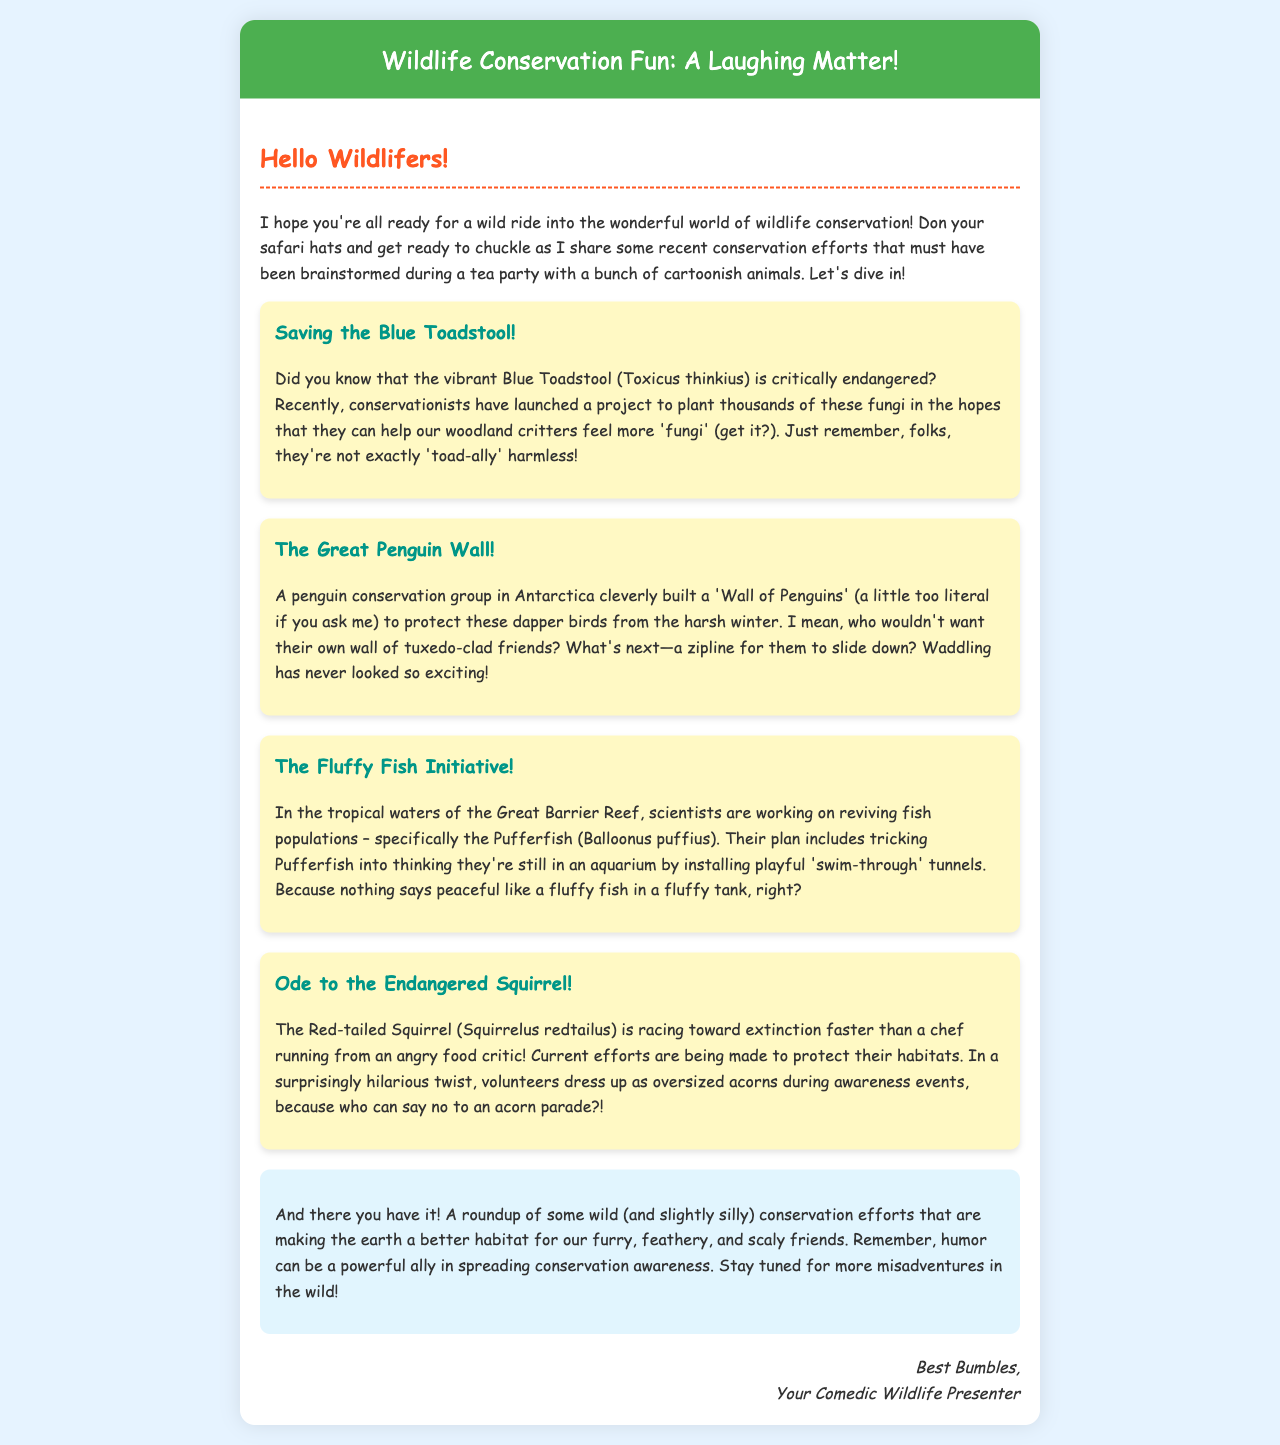What is the title of the document? The title is stated in the head section of the HTML document.
Answer: Wildlife Conservation Fun: A Laughing Matter! How many conservation efforts are mentioned? The document outlines four distinct conservation efforts.
Answer: Four What species is referred to as critically endangered? The document explicitly mentions the Blue Toadstool species as critically endangered.
Answer: Blue Toadstool What humorous solution was proposed for the Red-tailed Squirrel? The document describes volunteers dressing as oversized acorns during awareness events.
Answer: Oversized acorns What is the main color of the section backgrounds? The sections in the document have a specific light yellow background color mentioned in the style.
Answer: Light yellow Which bird species is associated with a ‘Wall of Penguins’? The document mentions the dapper birds related to the phrase.
Answer: Penguins What is the primary restoration focus in the Great Barrier Reef? The document highlights that scientists are focusing on reviving fish populations.
Answer: Fish populations What type of humor is incorporated into the conservation efforts? The document emphasizes that the conservation efforts are presented in a humorous way.
Answer: Humor Who is the sign-off from? The document includes a sign-off section with a specific name.
Answer: Best Bumbles 